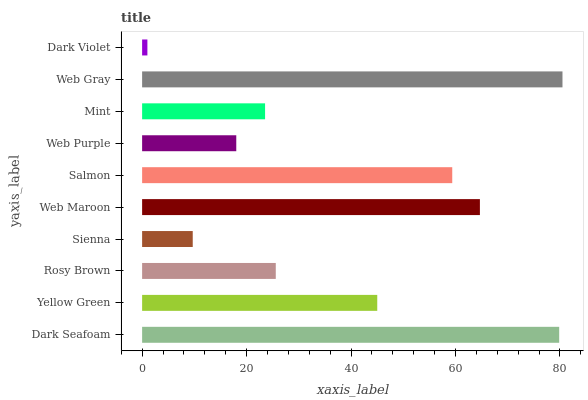Is Dark Violet the minimum?
Answer yes or no. Yes. Is Web Gray the maximum?
Answer yes or no. Yes. Is Yellow Green the minimum?
Answer yes or no. No. Is Yellow Green the maximum?
Answer yes or no. No. Is Dark Seafoam greater than Yellow Green?
Answer yes or no. Yes. Is Yellow Green less than Dark Seafoam?
Answer yes or no. Yes. Is Yellow Green greater than Dark Seafoam?
Answer yes or no. No. Is Dark Seafoam less than Yellow Green?
Answer yes or no. No. Is Yellow Green the high median?
Answer yes or no. Yes. Is Rosy Brown the low median?
Answer yes or no. Yes. Is Dark Seafoam the high median?
Answer yes or no. No. Is Web Purple the low median?
Answer yes or no. No. 